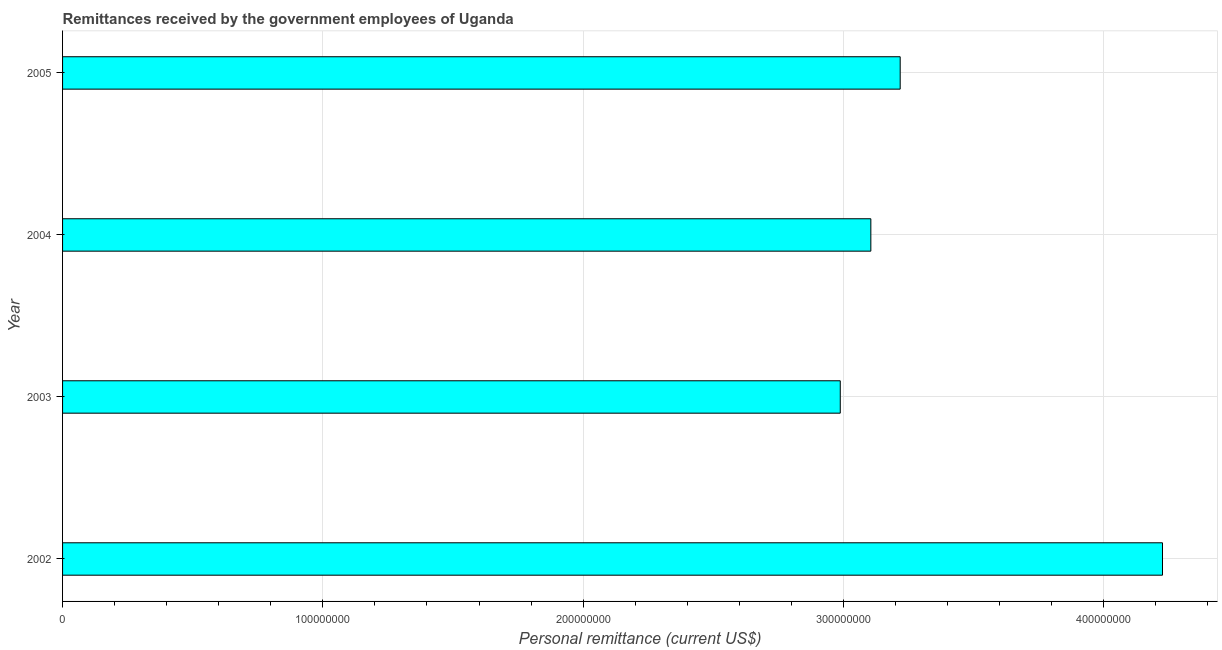Does the graph contain any zero values?
Provide a succinct answer. No. Does the graph contain grids?
Make the answer very short. Yes. What is the title of the graph?
Your answer should be very brief. Remittances received by the government employees of Uganda. What is the label or title of the X-axis?
Provide a short and direct response. Personal remittance (current US$). What is the label or title of the Y-axis?
Offer a terse response. Year. What is the personal remittances in 2005?
Offer a terse response. 3.22e+08. Across all years, what is the maximum personal remittances?
Ensure brevity in your answer.  4.23e+08. Across all years, what is the minimum personal remittances?
Your answer should be compact. 2.99e+08. In which year was the personal remittances maximum?
Offer a very short reply. 2002. What is the sum of the personal remittances?
Provide a succinct answer. 1.35e+09. What is the difference between the personal remittances in 2002 and 2003?
Keep it short and to the point. 1.24e+08. What is the average personal remittances per year?
Provide a short and direct response. 3.38e+08. What is the median personal remittances?
Your answer should be very brief. 3.16e+08. In how many years, is the personal remittances greater than 100000000 US$?
Offer a very short reply. 4. Do a majority of the years between 2003 and 2004 (inclusive) have personal remittances greater than 420000000 US$?
Give a very brief answer. No. Is the personal remittances in 2004 less than that in 2005?
Keep it short and to the point. Yes. Is the difference between the personal remittances in 2002 and 2004 greater than the difference between any two years?
Your response must be concise. No. What is the difference between the highest and the second highest personal remittances?
Give a very brief answer. 1.01e+08. Is the sum of the personal remittances in 2002 and 2005 greater than the maximum personal remittances across all years?
Give a very brief answer. Yes. What is the difference between the highest and the lowest personal remittances?
Give a very brief answer. 1.24e+08. Are all the bars in the graph horizontal?
Provide a succinct answer. Yes. How many years are there in the graph?
Provide a short and direct response. 4. What is the difference between two consecutive major ticks on the X-axis?
Provide a succinct answer. 1.00e+08. Are the values on the major ticks of X-axis written in scientific E-notation?
Keep it short and to the point. No. What is the Personal remittance (current US$) in 2002?
Make the answer very short. 4.23e+08. What is the Personal remittance (current US$) in 2003?
Your answer should be compact. 2.99e+08. What is the Personal remittance (current US$) in 2004?
Provide a short and direct response. 3.11e+08. What is the Personal remittance (current US$) of 2005?
Provide a short and direct response. 3.22e+08. What is the difference between the Personal remittance (current US$) in 2002 and 2003?
Provide a short and direct response. 1.24e+08. What is the difference between the Personal remittance (current US$) in 2002 and 2004?
Offer a terse response. 1.12e+08. What is the difference between the Personal remittance (current US$) in 2002 and 2005?
Your answer should be compact. 1.01e+08. What is the difference between the Personal remittance (current US$) in 2003 and 2004?
Ensure brevity in your answer.  -1.17e+07. What is the difference between the Personal remittance (current US$) in 2003 and 2005?
Offer a terse response. -2.30e+07. What is the difference between the Personal remittance (current US$) in 2004 and 2005?
Offer a very short reply. -1.13e+07. What is the ratio of the Personal remittance (current US$) in 2002 to that in 2003?
Provide a succinct answer. 1.41. What is the ratio of the Personal remittance (current US$) in 2002 to that in 2004?
Your response must be concise. 1.36. What is the ratio of the Personal remittance (current US$) in 2002 to that in 2005?
Give a very brief answer. 1.31. What is the ratio of the Personal remittance (current US$) in 2003 to that in 2005?
Provide a short and direct response. 0.93. 